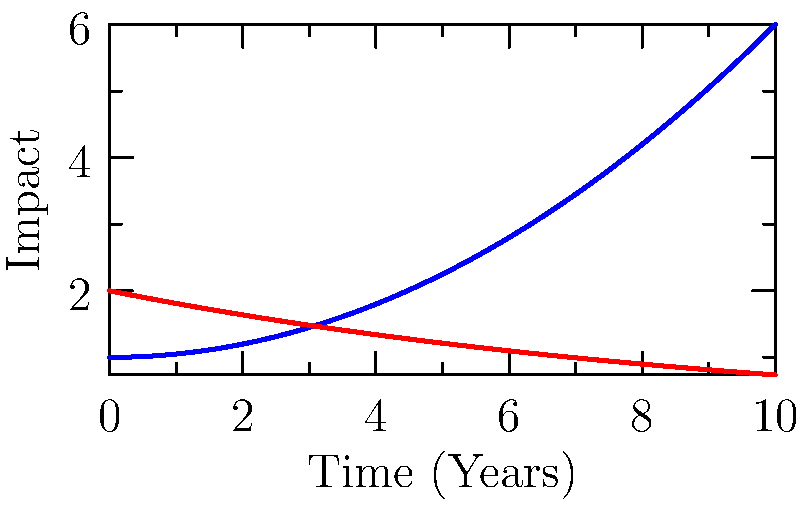Based on the infographic illustrating the impact of climate change on cultural heritage, which element shows a more rapid decline over time, and how might this information be effectively communicated to the local tribal community? To answer this question, let's analyze the infographic step-by-step:

1. The graph shows two curves: blue for Cultural Heritage Sites and red for Traditional Practices.

2. The x-axis represents Time (Years), while the y-axis represents Impact.

3. The blue curve (Cultural Heritage Sites) is increasing over time, following a quadratic function: $f(x) = 0.05x^2 + 1$.

4. The red curve (Traditional Practices) is decreasing over time, following an exponential decay function: $g(x) = 2e^{-0.1x}$.

5. Comparing the two curves, we can see that Traditional Practices (red curve) shows a more rapid decline over time.

6. To effectively communicate this information to the local tribal community:
   a) Use simple language and avoid technical terms.
   b) Relate the graph to real-life examples from the community.
   c) Emphasize the importance of preserving traditional practices.
   d) Discuss potential solutions and community involvement in conservation efforts.

7. As a heritage conservationist, you could organize community meetings to present this information, using visual aids and storytelling techniques to make the data more relatable and understandable to the local tribal community.
Answer: Traditional Practices; community meetings with visual aids and storytelling 